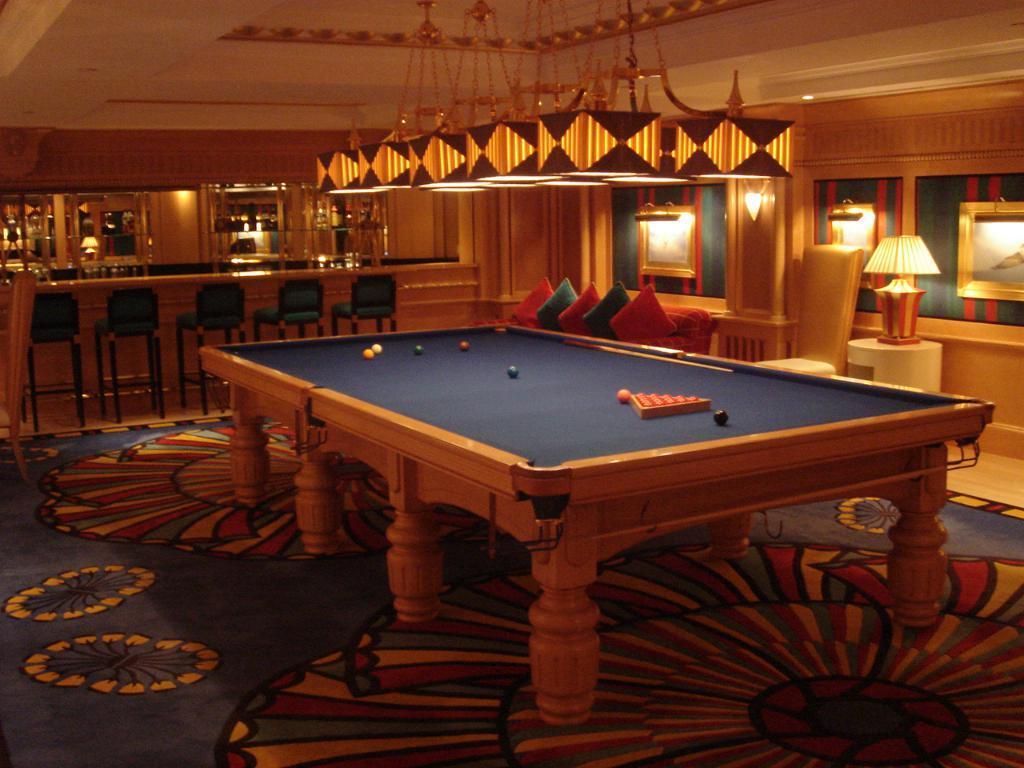How would you summarize this image in a sentence or two? In this picture there is a snooker table with some balls and the snooker stick kept on it. In the backdrop a there is a couple of glasses and some wine bottles there also some chairs and on the right there is a lamp, a couch with pillows. 